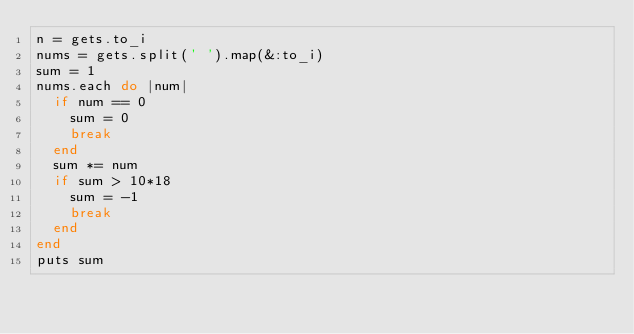<code> <loc_0><loc_0><loc_500><loc_500><_Ruby_>n = gets.to_i
nums = gets.split(' ').map(&:to_i)
sum = 1
nums.each do |num|
  if num == 0
    sum = 0
    break
  end
  sum *= num
  if sum > 10*18
    sum = -1
    break
  end
end
puts sum</code> 